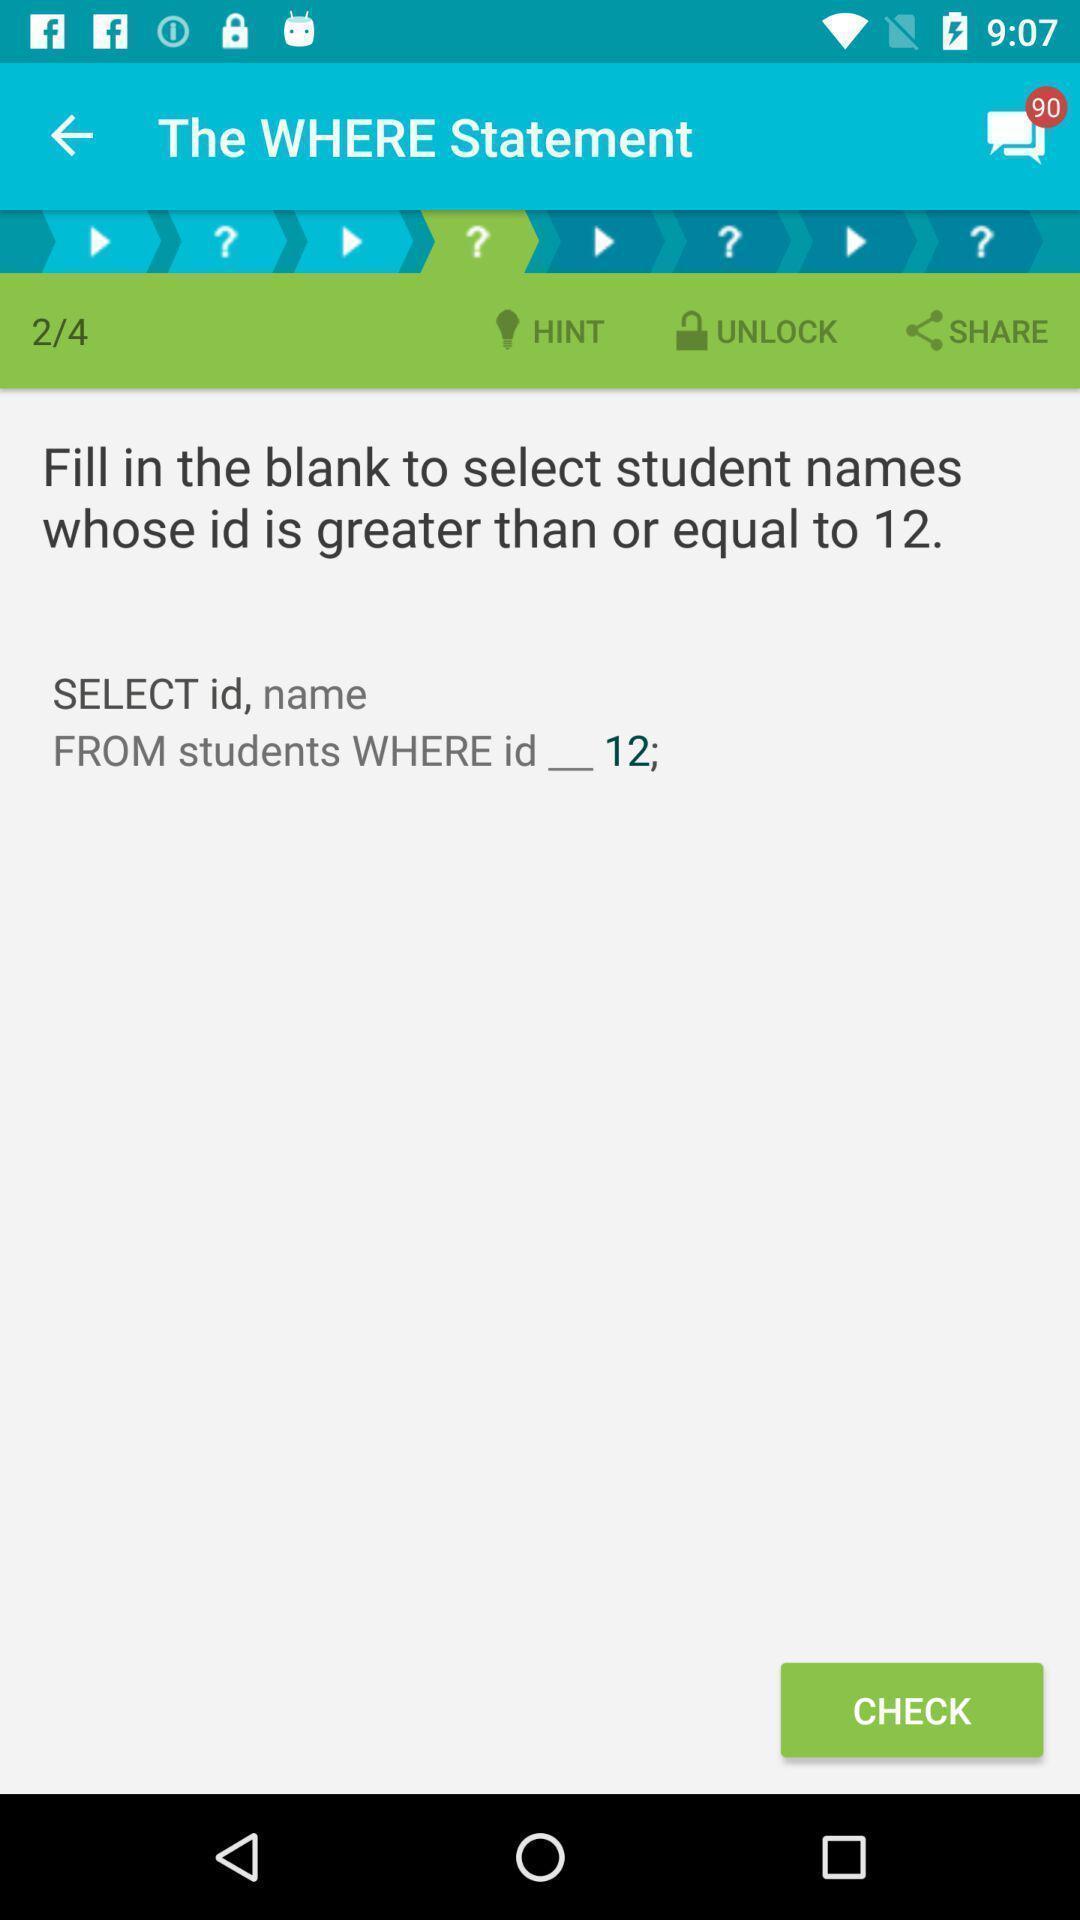Please provide a description for this image. Screen displaying the page of a learning app. 